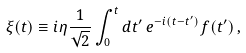Convert formula to latex. <formula><loc_0><loc_0><loc_500><loc_500>\xi ( t ) \equiv i \eta \frac { 1 } { \sqrt { 2 } } \int _ { 0 } ^ { t } { d t ^ { \prime } } \, e ^ { - i ( t - t ^ { \prime } ) } f ( t ^ { \prime } ) \, ,</formula> 